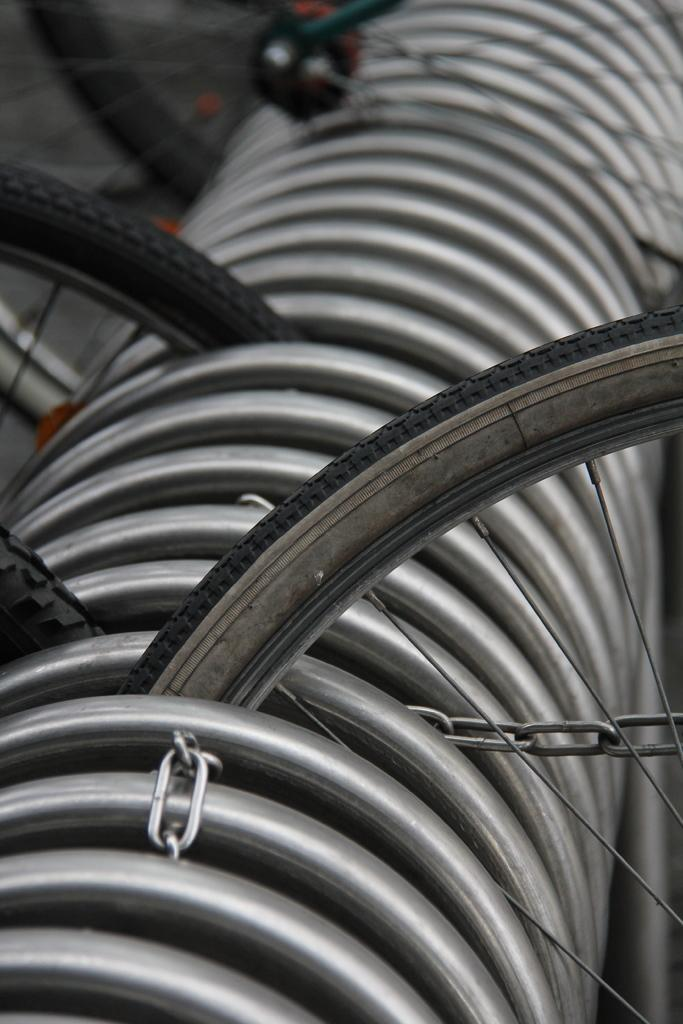What type of wheels can be seen in the image? There are bicycle wheels in the image. Are there any other parts of a bicycle visible in the image? The facts provided do not mention any other parts of a bicycle. Can you describe the appearance of the bicycle wheels? The appearance of the bicycle wheels cannot be determined from the provided facts. What type of expert is buried in the cemetery in the image? There is no cemetery present in the image, and therefore no expert can be identified as being buried there. 